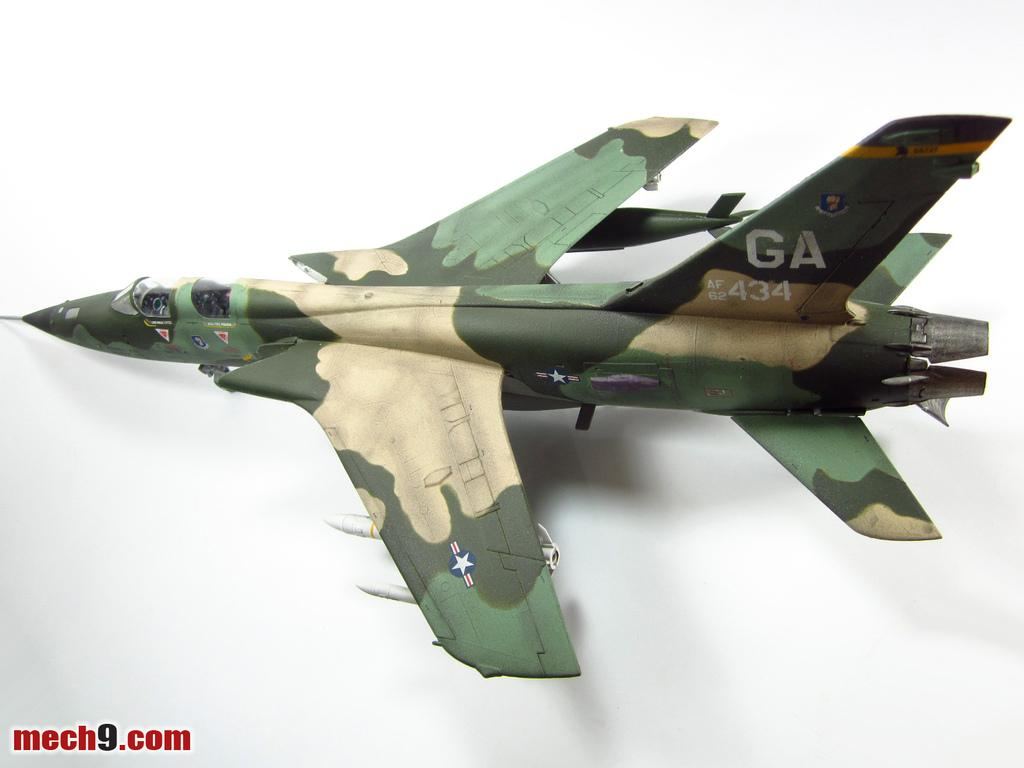<image>
Share a concise interpretation of the image provided. A camouflaged jet has the letters GA on the tail. 